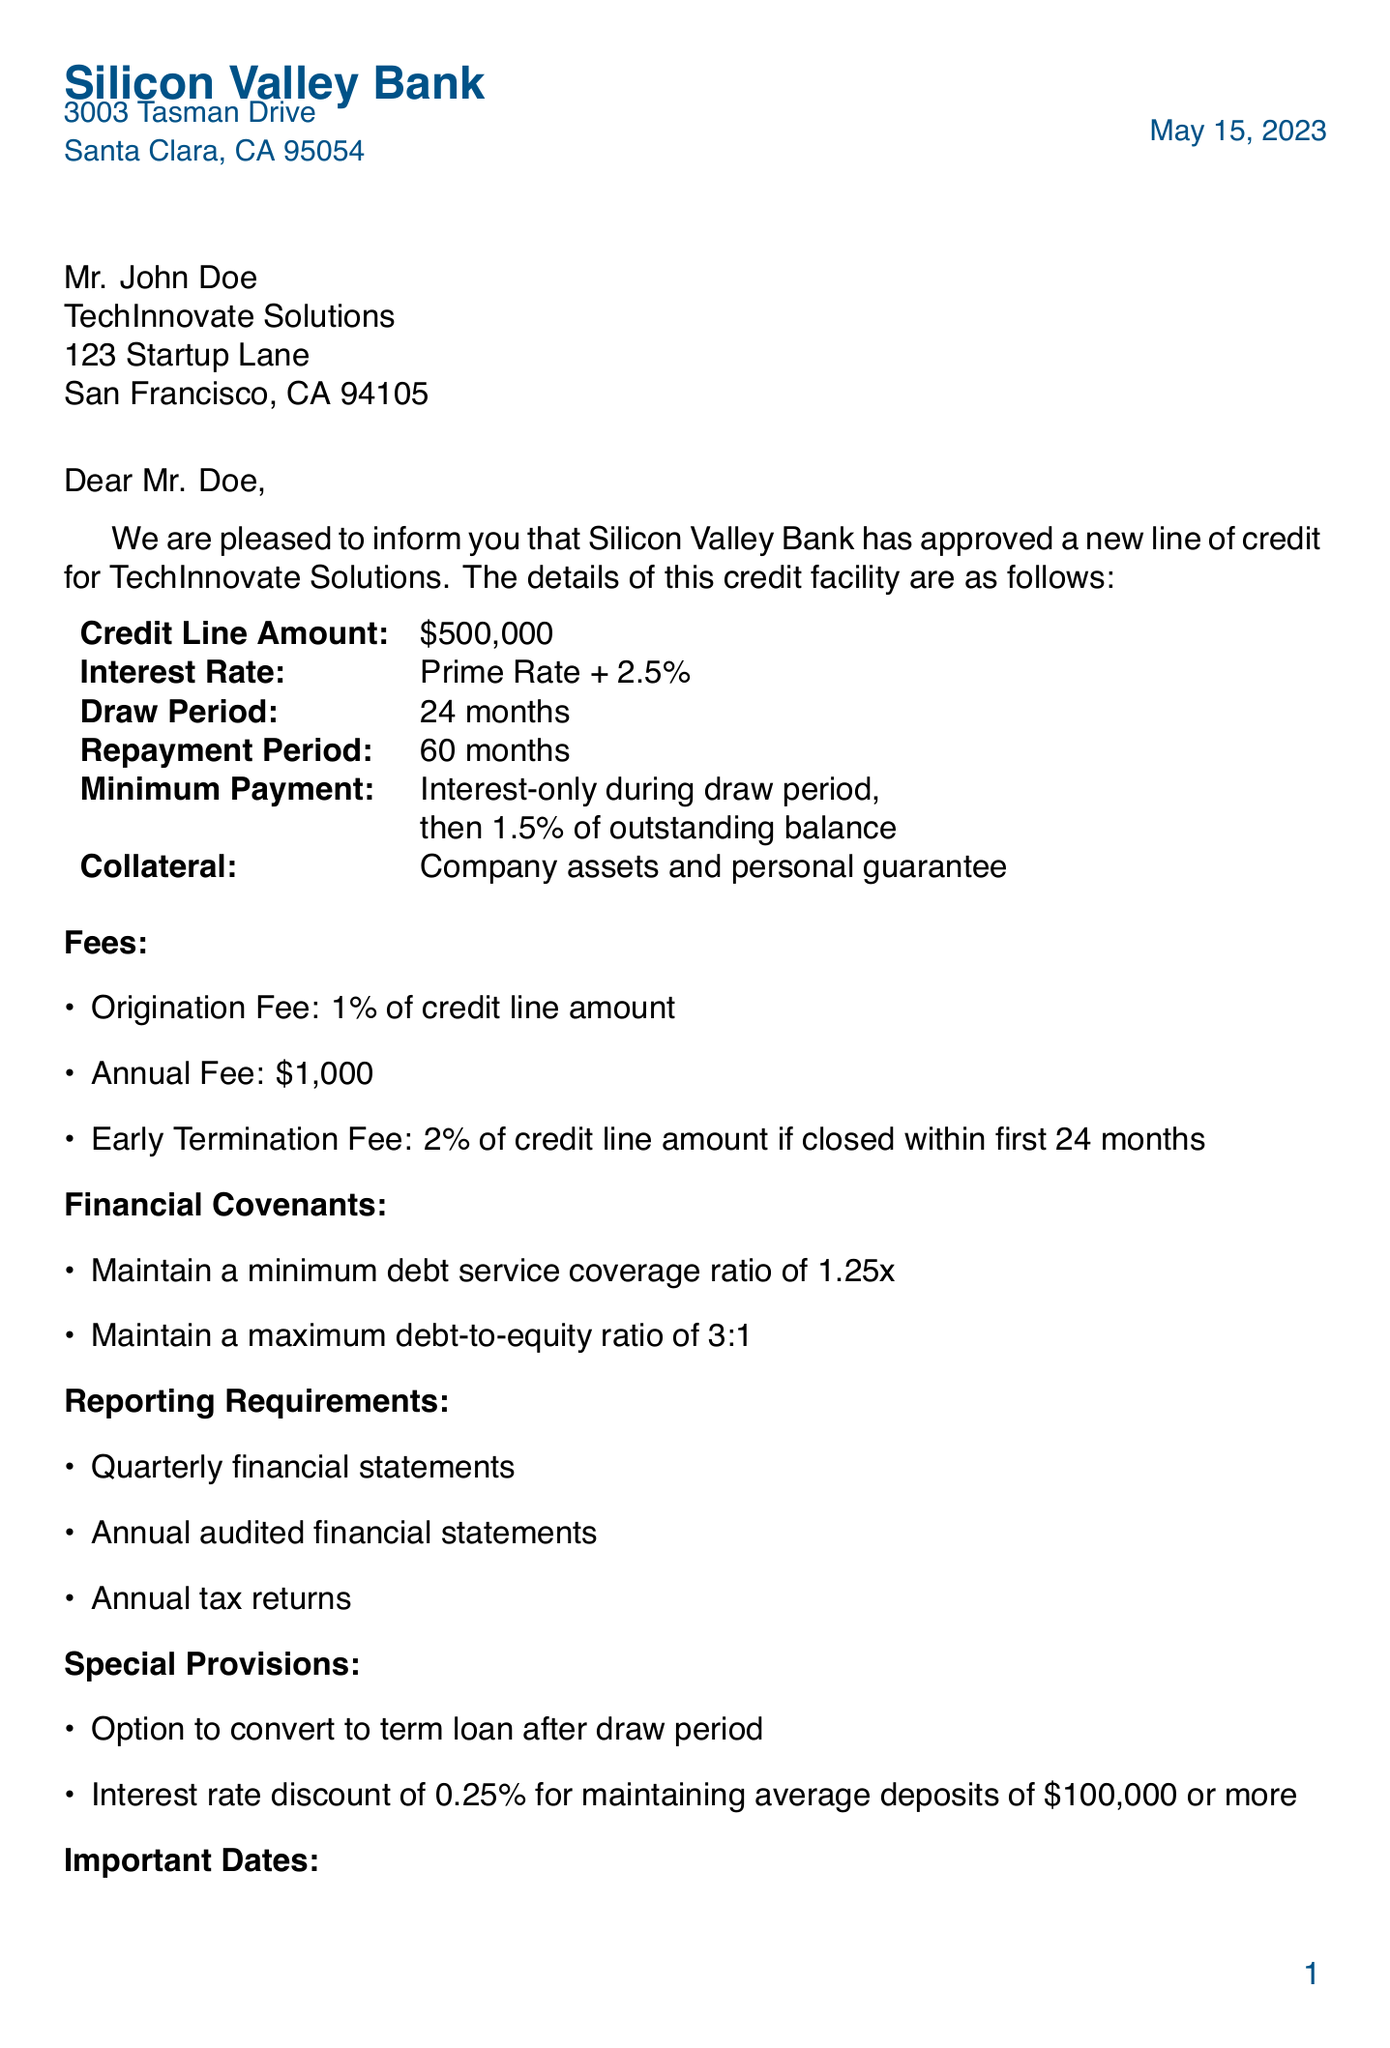What is the credit line amount? The credit line amount is specified in the document as $500,000.
Answer: $500,000 What is the interest rate for the credit line? The interest rate is stated as Prime Rate + 2.5%.
Answer: Prime Rate + 2.5% What is the draw period duration? The duration of the draw period is mentioned as 24 months.
Answer: 24 months Who is the key contact for this line of credit? The document identifies Sarah Johnson as the Relationship Manager for contact.
Answer: Sarah Johnson What is the early termination fee percentage? The early termination fee percentage is clearly specified as 2%.
Answer: 2% What is the minimum debt service coverage ratio required? The minimum debt service coverage ratio is outlined in the financial covenants as 1.25x.
Answer: 1.25x When is the first draw date? The first draw date is noted in the important dates section as July 1, 2023.
Answer: July 1, 2023 What document is needed to authorize the credit line? The document needed to authorize the credit line is the corporate resolution.
Answer: Corporate resolution What special provision offers an interest rate discount? The provision for an interest rate discount states maintaining average deposits of $100,000 or more.
Answer: Maintaining average deposits of $100,000 or more 